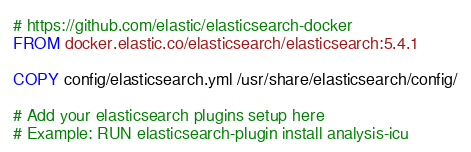Convert code to text. <code><loc_0><loc_0><loc_500><loc_500><_Dockerfile_># https://github.com/elastic/elasticsearch-docker
FROM docker.elastic.co/elasticsearch/elasticsearch:5.4.1

COPY config/elasticsearch.yml /usr/share/elasticsearch/config/

# Add your elasticsearch plugins setup here
# Example: RUN elasticsearch-plugin install analysis-icu</code> 